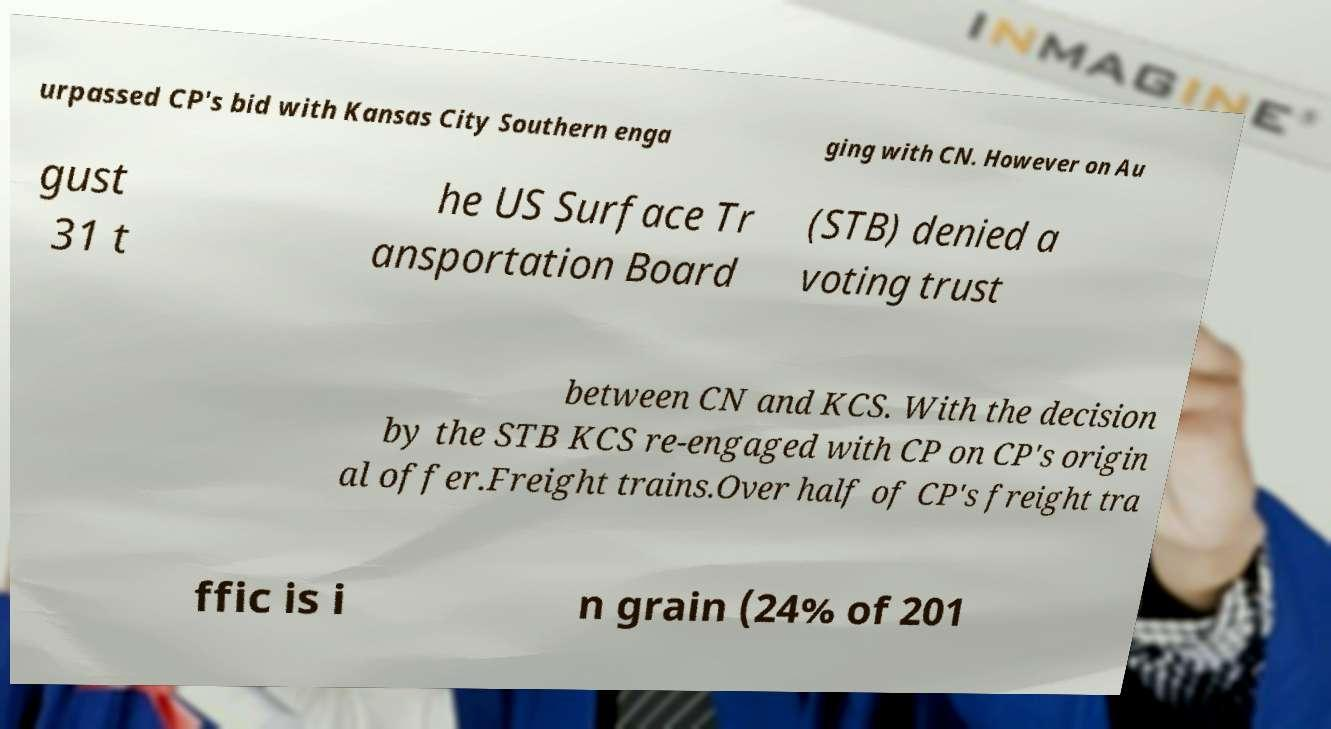Please read and relay the text visible in this image. What does it say? urpassed CP's bid with Kansas City Southern enga ging with CN. However on Au gust 31 t he US Surface Tr ansportation Board (STB) denied a voting trust between CN and KCS. With the decision by the STB KCS re-engaged with CP on CP's origin al offer.Freight trains.Over half of CP's freight tra ffic is i n grain (24% of 201 